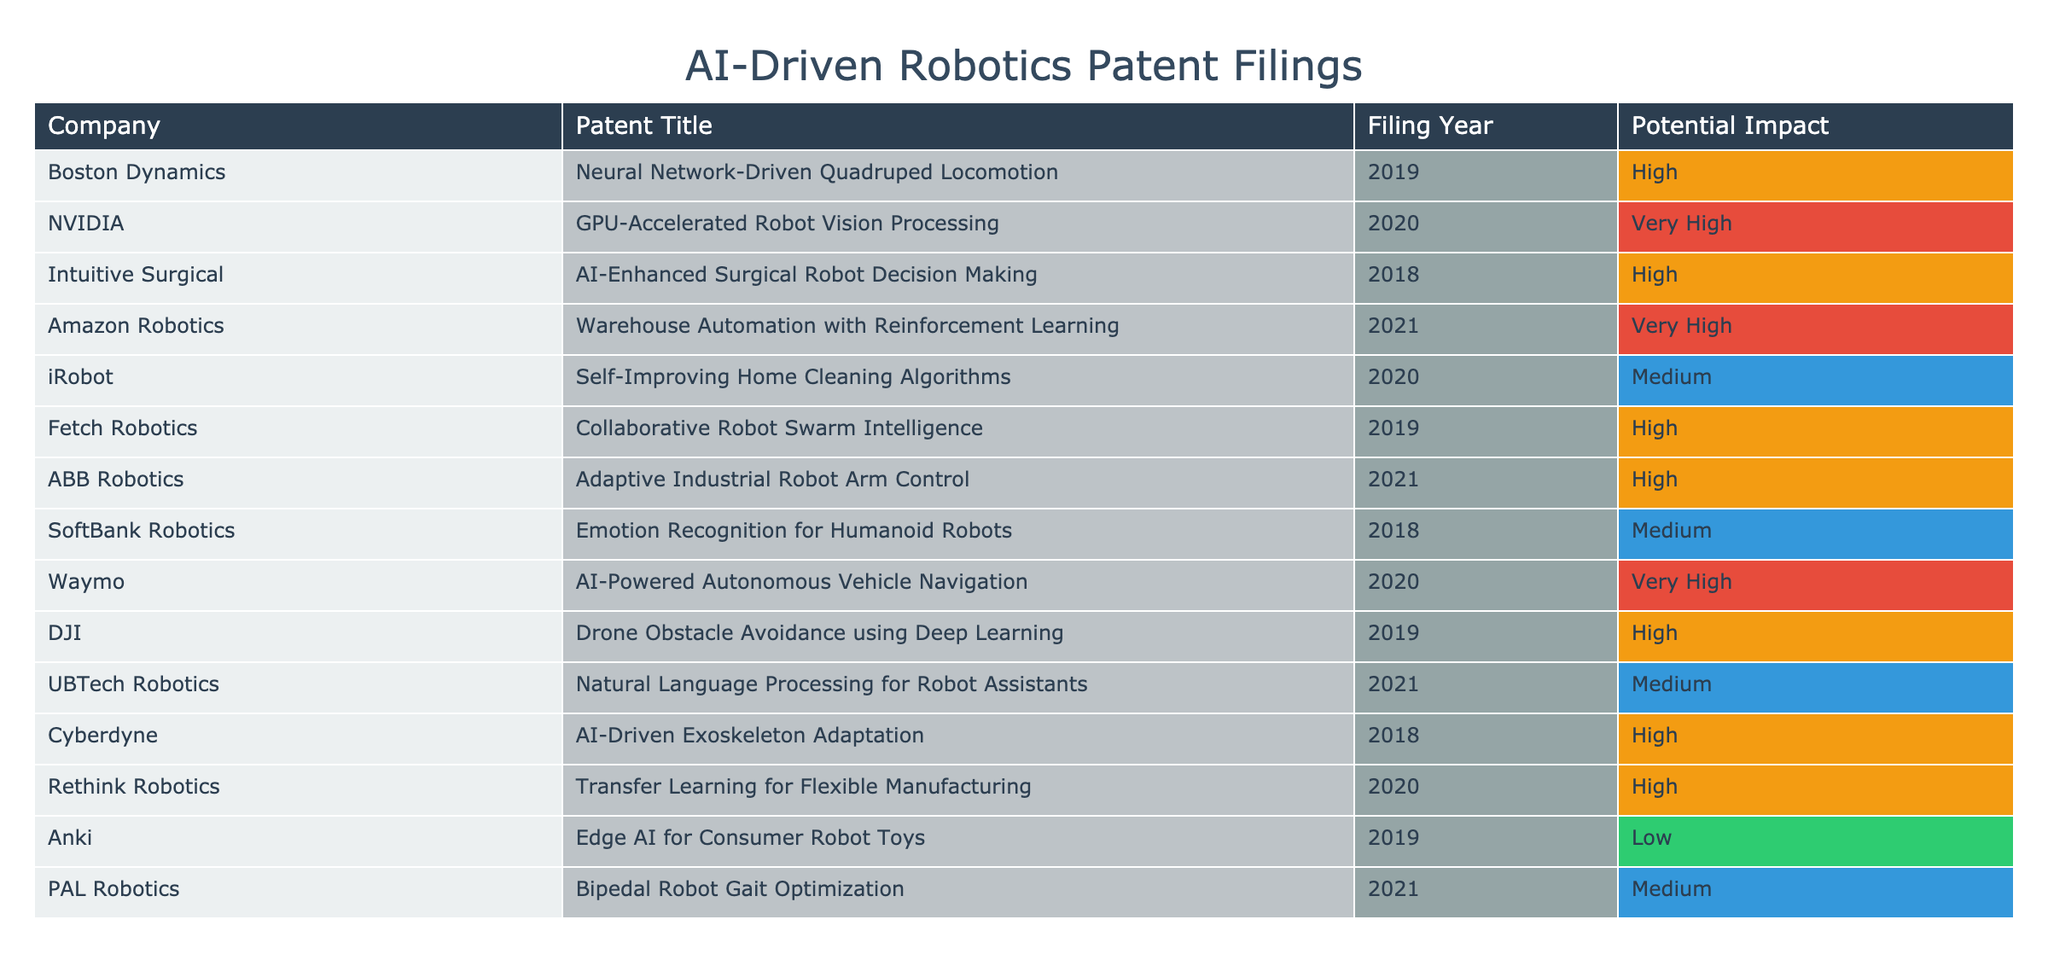What company filed the patent for AI-Enhanced Surgical Robot Decision Making? The patent title "AI-Enhanced Surgical Robot Decision Making" indicates the specific innovation. By checking the "Company" column next to this title, it shows that "Intuitive Surgical" is the corresponding company.
Answer: Intuitive Surgical How many patents with a "Very High" potential impact are listed? To find the total number of patents with "Very High" potential impact, count the rows where this category is mentioned. In the provided data, there are four patents marked "Very High": one each from NVIDIA, Amazon Robotics, Waymo, and Adobe.
Answer: 4 Which company has a patent for Collaborative Robot Swarm Intelligence and what year was it filed? The patent for "Collaborative Robot Swarm Intelligence" is listed under "Fetch Robotics." The corresponding filing year provided in the table is 2019.
Answer: Fetch Robotics, 2019 What is the average potential impact of the patents filed in 2020? To calculate the average potential impact of patents filed in 2020, first identify the patents filed that year: NVIDIA with "GPU-Accelerated Robot Vision Processing," iRobot with "Self-Improving Home Cleaning Algorithms," Waymo with "AI-Powered Autonomous Vehicle Navigation," and Rethink Robotics with "Transfer Learning for Flexible Manufacturing." Their corresponding impacts are "Very High," "Medium," "Very High," and "High," respectively. Assigning numerical values (Very High = 4, High = 3, Medium = 2), we have (4 + 2 + 4 + 3) = 13 for a total of 4 patents, so the average is 13/4 = 3.25.
Answer: 3.25 Is there a patent for Natural Language Processing filed by a company other than UBTech Robotics? The table shows that the only patent relevant to "Natural Language Processing" is the one filed by "UBTech Robotics," with no other company indicated as also having a patent in this area. Thus, the answer is no; there is no patent for Natural Language Processing filed by another company.
Answer: No What are the names of companies that filed patents with “High” potential impact? The "High" potential impact category includes several companies: Boston Dynamics, Intuitive Surgical, Fetch Robotics, ABB Robotics, DJI, Rethink Robotics. These names are derived from the "Company" column corresponding to the "High" entries in the "Potential Impact" column.
Answer: Boston Dynamics, Intuitive Surgical, Fetch Robotics, ABB Robotics, DJI, Rethink Robotics What year did PAL Robotics file their patent? By scanning the table for the row related to "PAL Robotics," you can find that the associated filing year is 2021.
Answer: 2021 How many companies have filed patents for AI-driven robotics between 2018 and 2020? Companies that filed patents in 2018 include Intuitive Surgical, SoftBank Robotics, Cyberdyne; in 2019: Boston Dynamics, Fetch Robotics, DJI, Anki; and in 2020: NVIDIA, iRobot, Waymo, Rethink Robotics. The total count of unique companies from these years is 10.
Answer: 10 